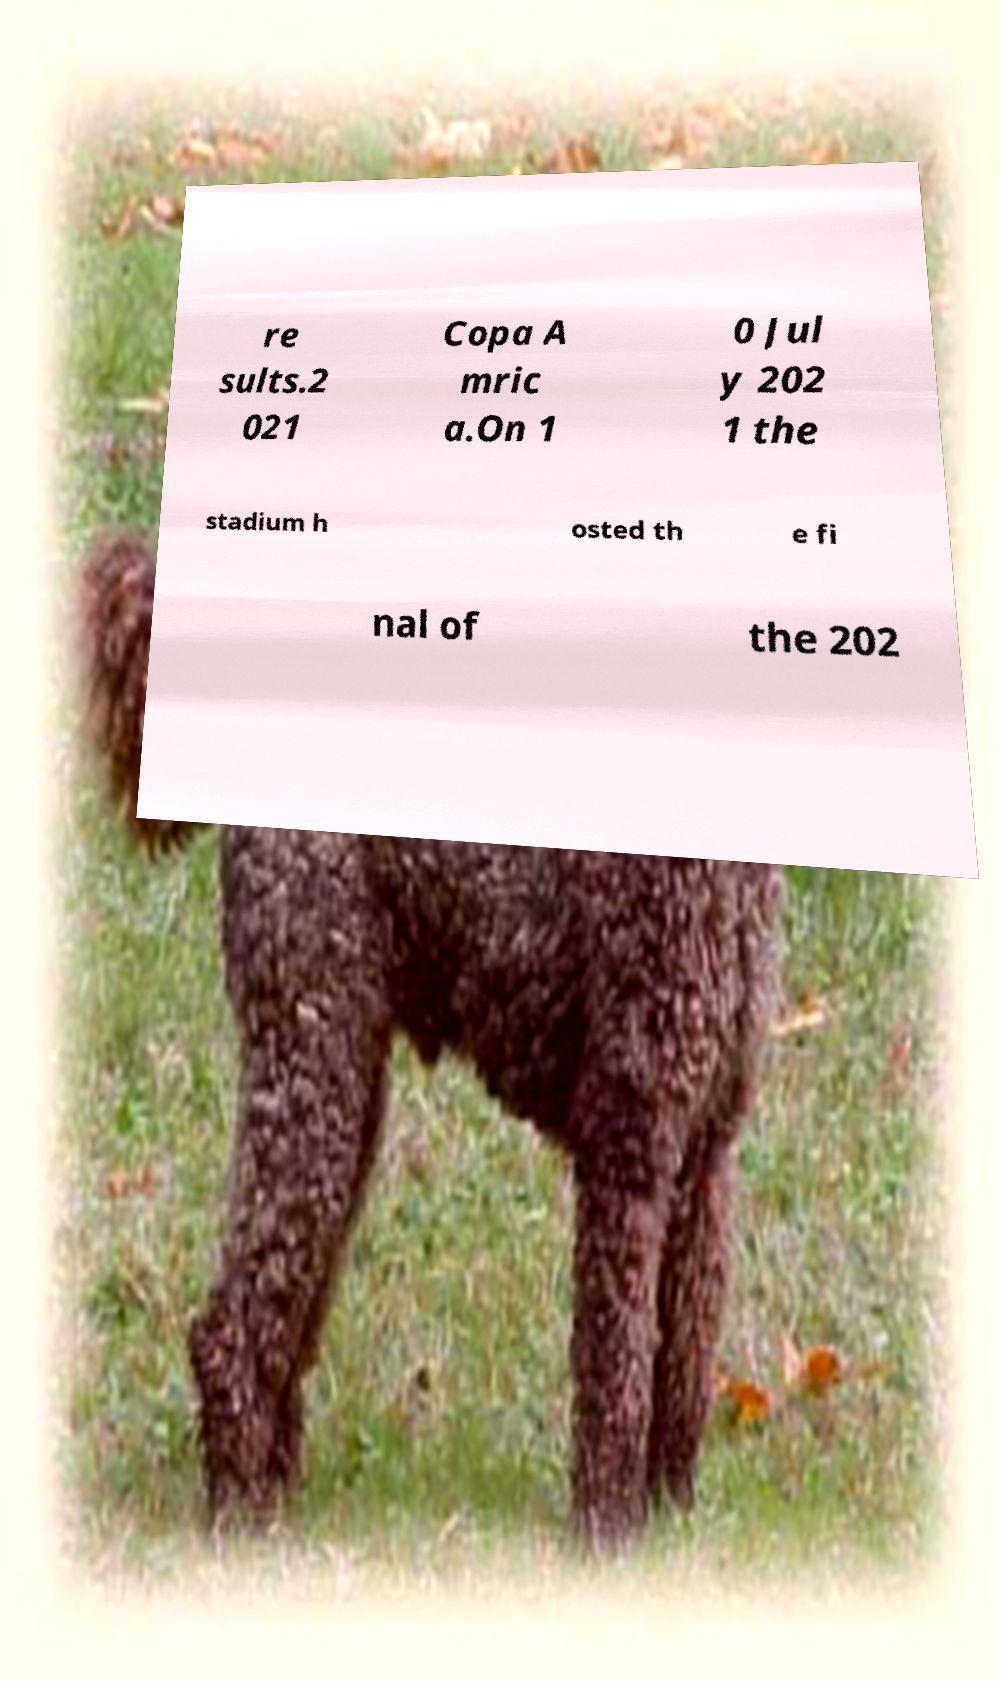Could you assist in decoding the text presented in this image and type it out clearly? re sults.2 021 Copa A mric a.On 1 0 Jul y 202 1 the stadium h osted th e fi nal of the 202 